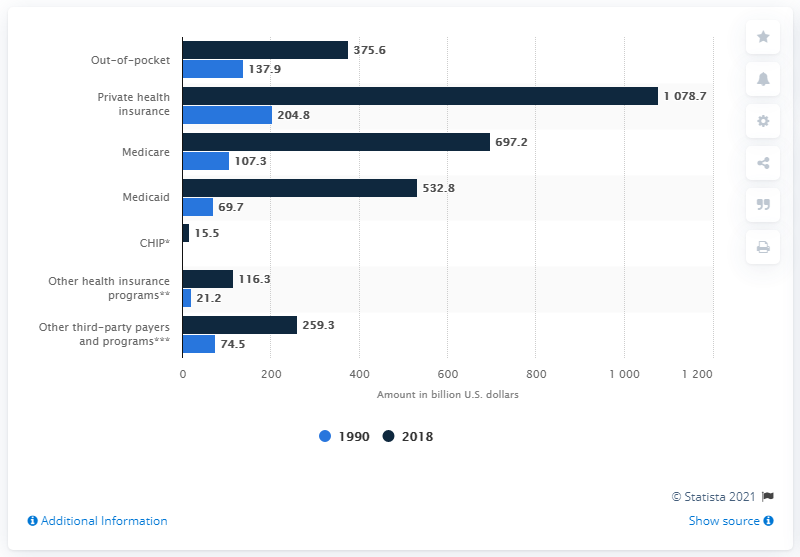Give some essential details in this illustration. In 1990, the Medicaid program funded approximately 69.7% of personal health care expenditures in the United States. 